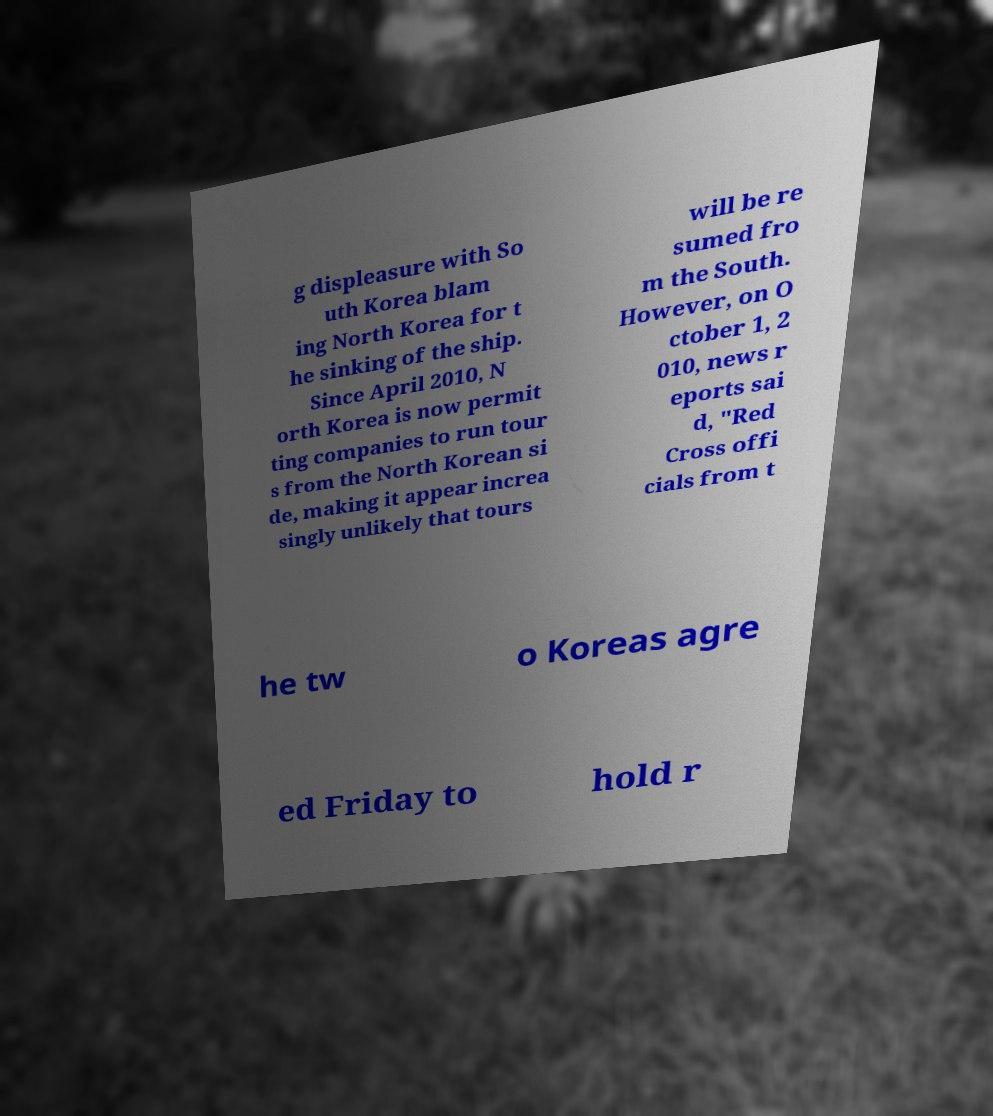I need the written content from this picture converted into text. Can you do that? g displeasure with So uth Korea blam ing North Korea for t he sinking of the ship. Since April 2010, N orth Korea is now permit ting companies to run tour s from the North Korean si de, making it appear increa singly unlikely that tours will be re sumed fro m the South. However, on O ctober 1, 2 010, news r eports sai d, "Red Cross offi cials from t he tw o Koreas agre ed Friday to hold r 